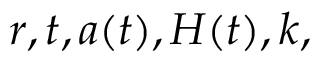Convert formula to latex. <formula><loc_0><loc_0><loc_500><loc_500>r , t , a ( t ) , H ( t ) , k ,</formula> 